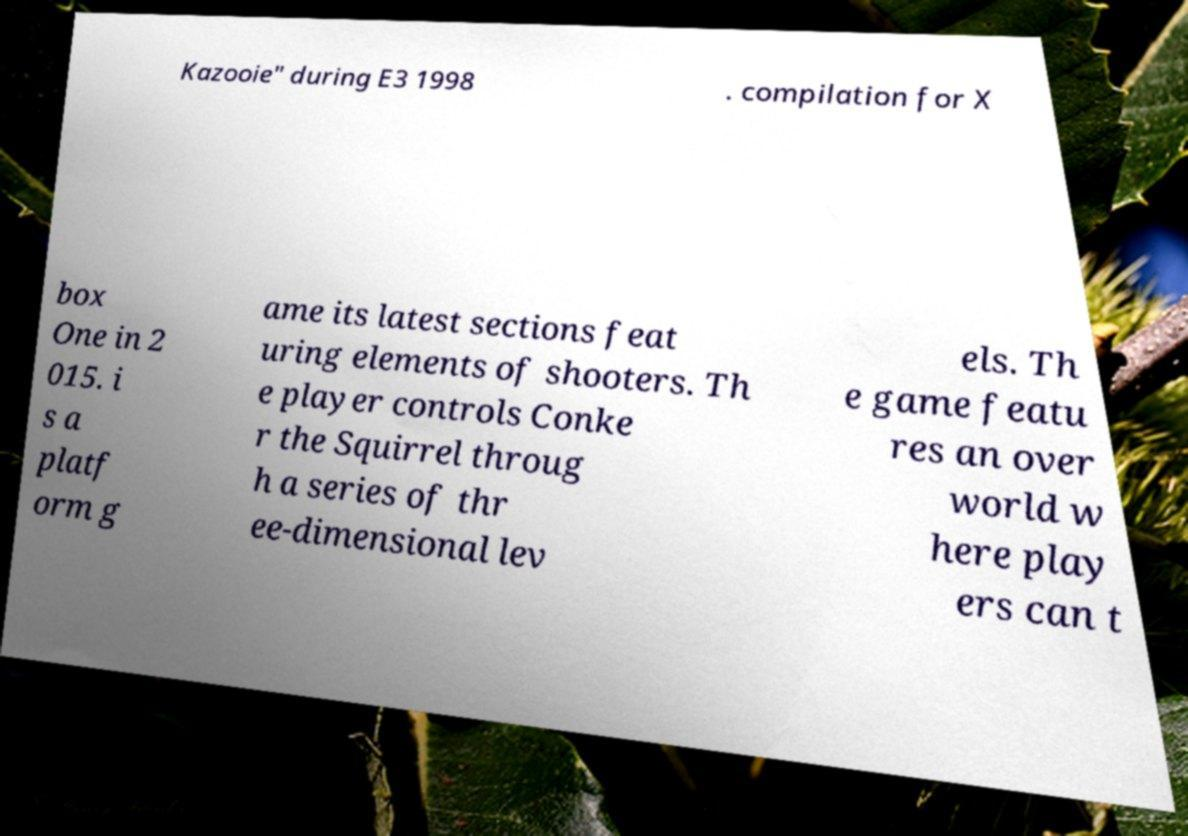Please read and relay the text visible in this image. What does it say? Kazooie" during E3 1998 . compilation for X box One in 2 015. i s a platf orm g ame its latest sections feat uring elements of shooters. Th e player controls Conke r the Squirrel throug h a series of thr ee-dimensional lev els. Th e game featu res an over world w here play ers can t 